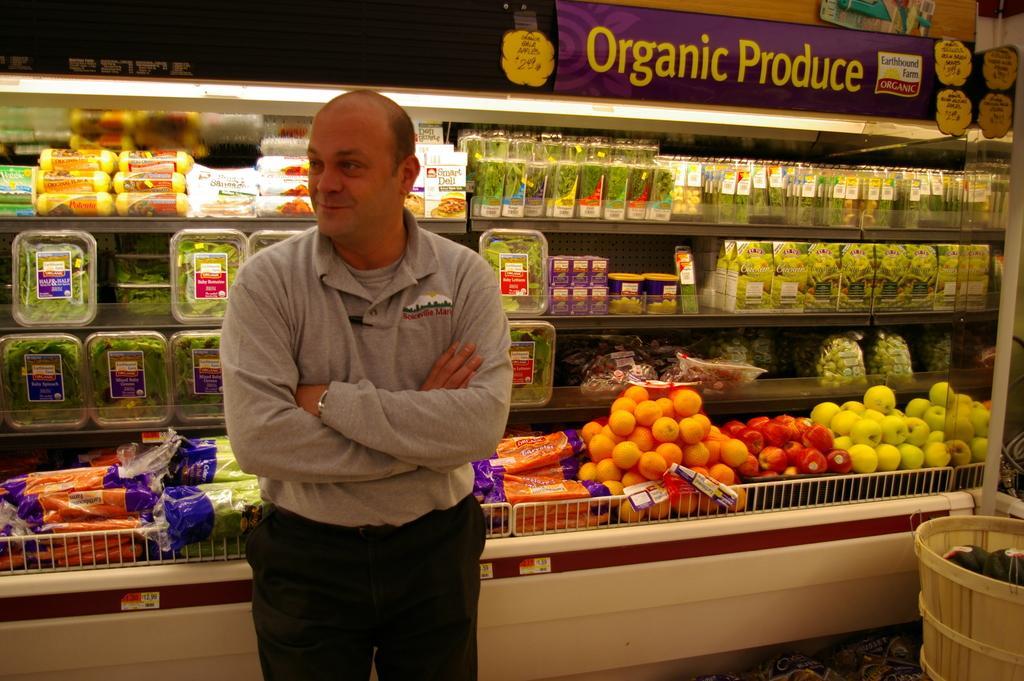Can you describe this image briefly? In this image in front there is a person. Behind him there are fruits, vegetables and some other objects on the rack. On the right side of the image there is a bucket. Inside the bucket there are few objects. 